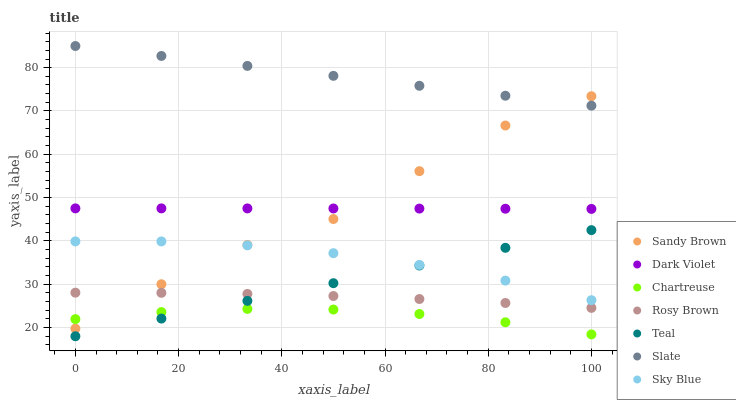Does Chartreuse have the minimum area under the curve?
Answer yes or no. Yes. Does Slate have the maximum area under the curve?
Answer yes or no. Yes. Does Rosy Brown have the minimum area under the curve?
Answer yes or no. No. Does Rosy Brown have the maximum area under the curve?
Answer yes or no. No. Is Teal the smoothest?
Answer yes or no. Yes. Is Sandy Brown the roughest?
Answer yes or no. Yes. Is Rosy Brown the smoothest?
Answer yes or no. No. Is Rosy Brown the roughest?
Answer yes or no. No. Does Teal have the lowest value?
Answer yes or no. Yes. Does Rosy Brown have the lowest value?
Answer yes or no. No. Does Slate have the highest value?
Answer yes or no. Yes. Does Rosy Brown have the highest value?
Answer yes or no. No. Is Chartreuse less than Rosy Brown?
Answer yes or no. Yes. Is Dark Violet greater than Chartreuse?
Answer yes or no. Yes. Does Rosy Brown intersect Sandy Brown?
Answer yes or no. Yes. Is Rosy Brown less than Sandy Brown?
Answer yes or no. No. Is Rosy Brown greater than Sandy Brown?
Answer yes or no. No. Does Chartreuse intersect Rosy Brown?
Answer yes or no. No. 